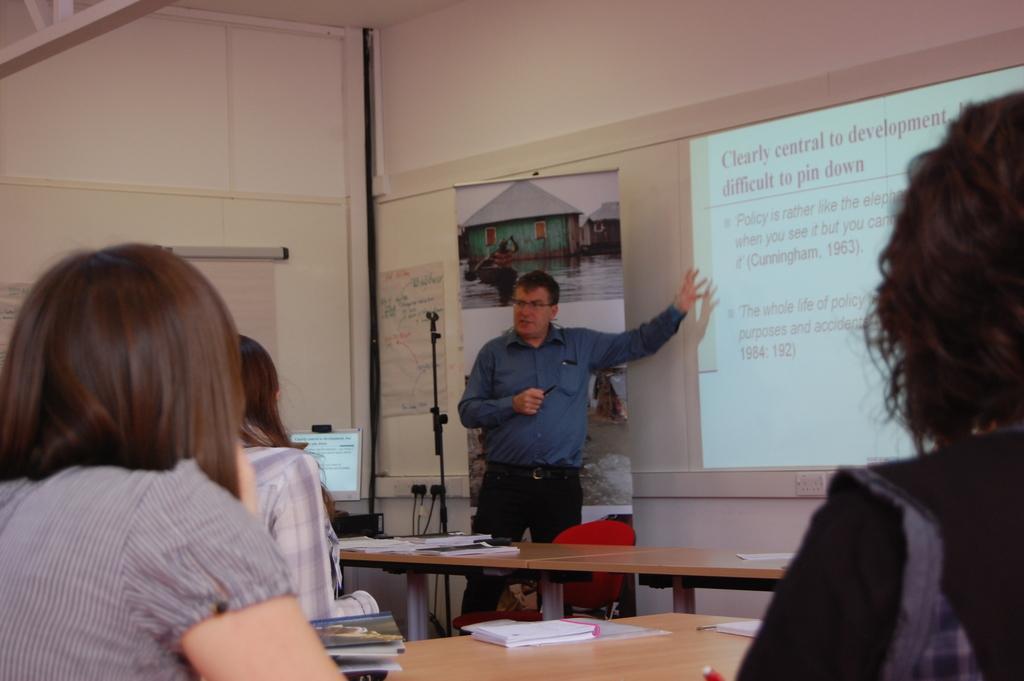Could you give a brief overview of what you see in this image? This man is standing in-front of a screen. Screen is attached to the wall. There are different type of posters on wall. This persons are sitting on a chair. On table there are books and papers. This is a monitor with screen. 